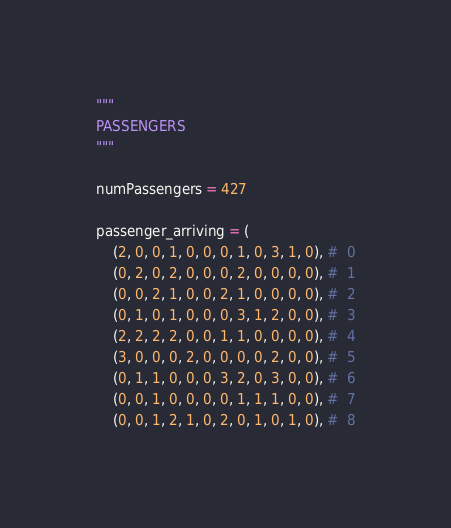Convert code to text. <code><loc_0><loc_0><loc_500><loc_500><_Python_>
"""
PASSENGERS
"""

numPassengers = 427

passenger_arriving = (
	(2, 0, 0, 1, 0, 0, 0, 1, 0, 3, 1, 0), #  0
	(0, 2, 0, 2, 0, 0, 0, 2, 0, 0, 0, 0), #  1
	(0, 0, 2, 1, 0, 0, 2, 1, 0, 0, 0, 0), #  2
	(0, 1, 0, 1, 0, 0, 0, 3, 1, 2, 0, 0), #  3
	(2, 2, 2, 2, 0, 0, 1, 1, 0, 0, 0, 0), #  4
	(3, 0, 0, 0, 2, 0, 0, 0, 0, 2, 0, 0), #  5
	(0, 1, 1, 0, 0, 0, 3, 2, 0, 3, 0, 0), #  6
	(0, 0, 1, 0, 0, 0, 0, 1, 1, 1, 0, 0), #  7
	(0, 0, 1, 2, 1, 0, 2, 0, 1, 0, 1, 0), #  8</code> 